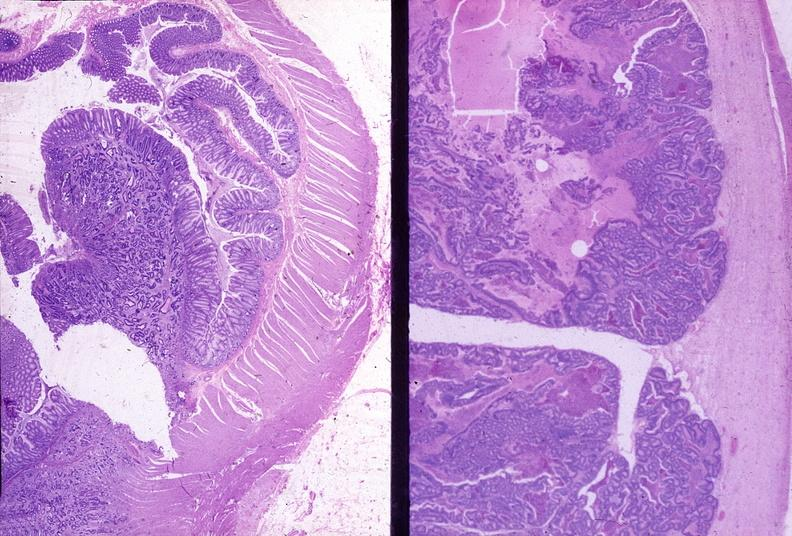does close-up of lesion show colon, adenocarcinoma?
Answer the question using a single word or phrase. No 